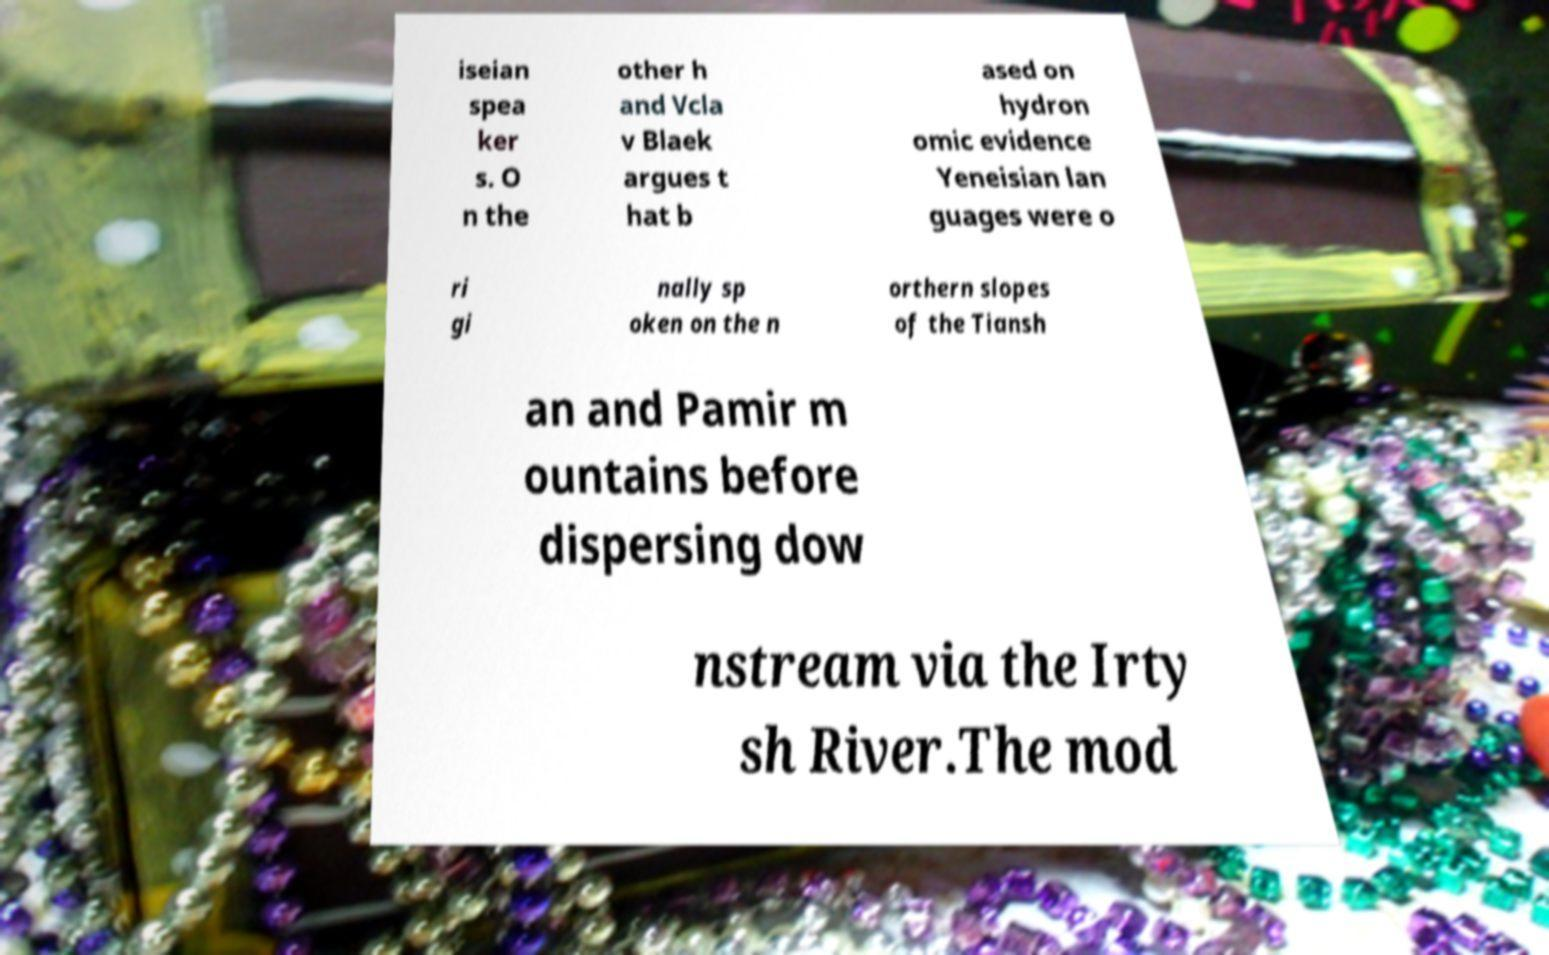What messages or text are displayed in this image? I need them in a readable, typed format. iseian spea ker s. O n the other h and Vcla v Blaek argues t hat b ased on hydron omic evidence Yeneisian lan guages were o ri gi nally sp oken on the n orthern slopes of the Tiansh an and Pamir m ountains before dispersing dow nstream via the Irty sh River.The mod 